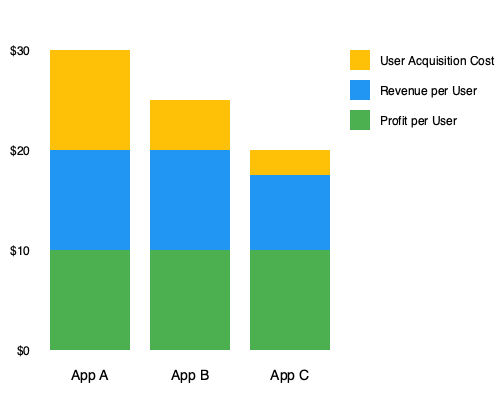Based on the stacked bar chart showing user acquisition costs, revenue per user, and profit per user for three educational mobile apps (A, B, and C), which app has the highest lifetime value (LTV) to customer acquisition cost (CAC) ratio? Explain your reasoning and calculate the exact ratio for the best-performing app. To determine which app has the highest LTV to CAC ratio, we need to follow these steps:

1. Identify the Customer Acquisition Cost (CAC) for each app:
   App A: $10
   App B: $5
   App C: $2.5

2. Calculate the Lifetime Value (LTV) for each app:
   LTV = Revenue per User + Profit per User
   App A: $10 + $10 = $20
   App B: $10 + $10 = $20
   App C: $5 + $10 = $15

3. Calculate the LTV to CAC ratio for each app:
   App A: $20 / $10 = 2
   App B: $20 / $5 = 4
   App C: $15 / $2.5 = 6

4. Compare the ratios:
   App A: 2
   App B: 4
   App C: 6

App C has the highest LTV to CAC ratio at 6, meaning for every dollar spent on acquiring a user, the app generates $6 in lifetime value.

5. Calculate the exact ratio for App C:
   LTV to CAC ratio = $15 / $2.5 = 6

Therefore, App C has the highest LTV to CAC ratio, making it the most efficient in terms of user acquisition and value generation.
Answer: App C, with an LTV to CAC ratio of 6. 